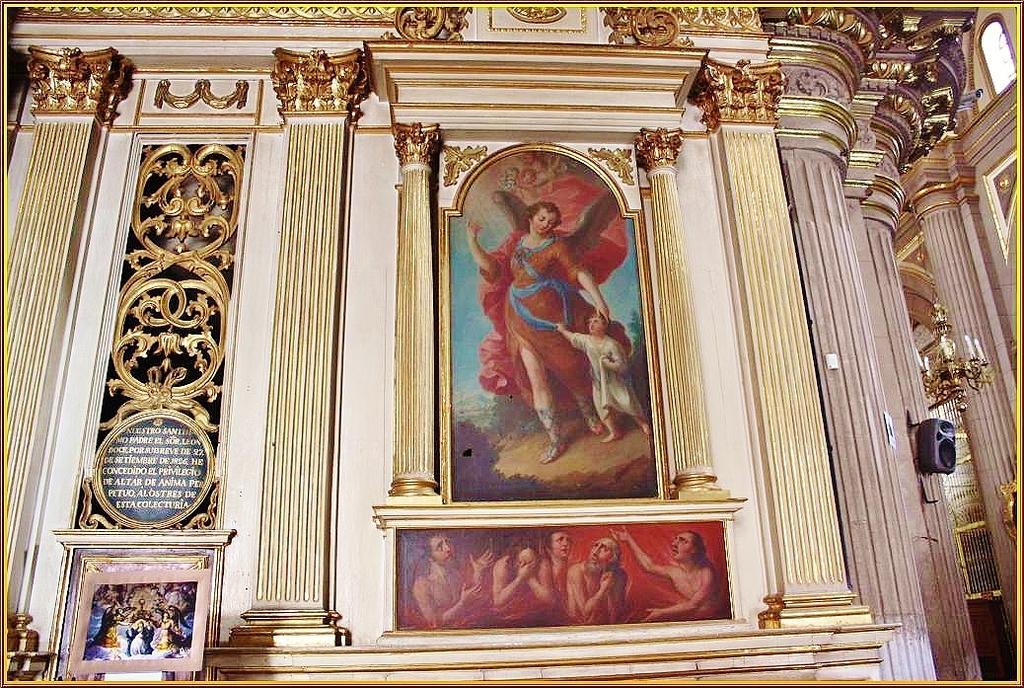Can you describe this image briefly? In this picture we can see photo frames on the wall, here we can see some designs, some text and some objects. 